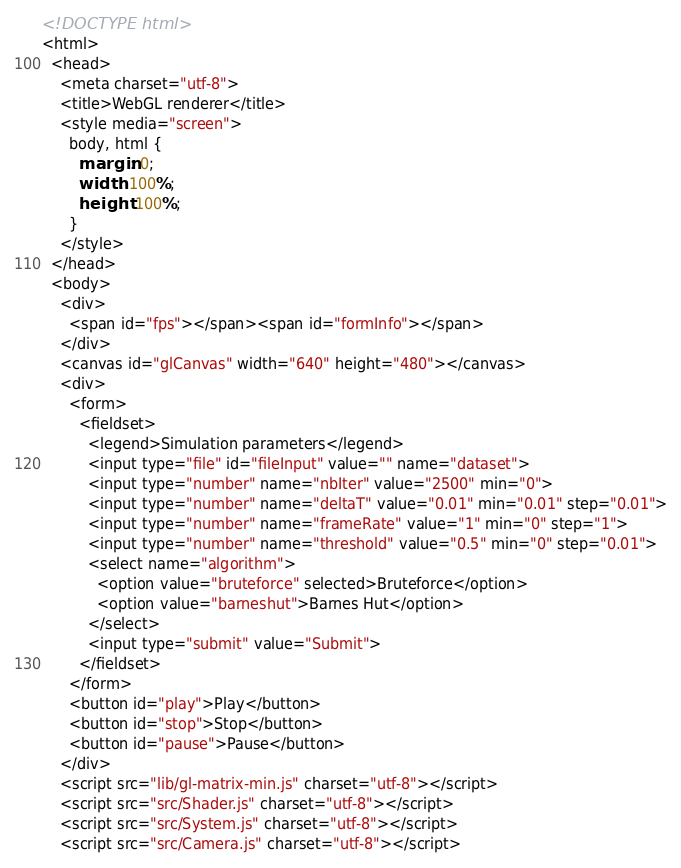Convert code to text. <code><loc_0><loc_0><loc_500><loc_500><_HTML_><!DOCTYPE html>
<html>
  <head>
    <meta charset="utf-8">
    <title>WebGL renderer</title>
    <style media="screen">
      body, html {
        margin: 0;
        width: 100%;
        height: 100%;
      }
    </style>
  </head>
  <body>
    <div>
      <span id="fps"></span><span id="formInfo"></span>
    </div>
    <canvas id="glCanvas" width="640" height="480"></canvas>
    <div>
      <form>
        <fieldset>
          <legend>Simulation parameters</legend>
          <input type="file" id="fileInput" value="" name="dataset">
          <input type="number" name="nbIter" value="2500" min="0">
          <input type="number" name="deltaT" value="0.01" min="0.01" step="0.01">
          <input type="number" name="frameRate" value="1" min="0" step="1">
          <input type="number" name="threshold" value="0.5" min="0" step="0.01">
          <select name="algorithm">
            <option value="bruteforce" selected>Bruteforce</option>
            <option value="barneshut">Barnes Hut</option>
          </select>
          <input type="submit" value="Submit">
        </fieldset>
      </form>
      <button id="play">Play</button>
      <button id="stop">Stop</button>
      <button id="pause">Pause</button>
    </div>
    <script src="lib/gl-matrix-min.js" charset="utf-8"></script>
    <script src="src/Shader.js" charset="utf-8"></script>
    <script src="src/System.js" charset="utf-8"></script>
    <script src="src/Camera.js" charset="utf-8"></script></code> 